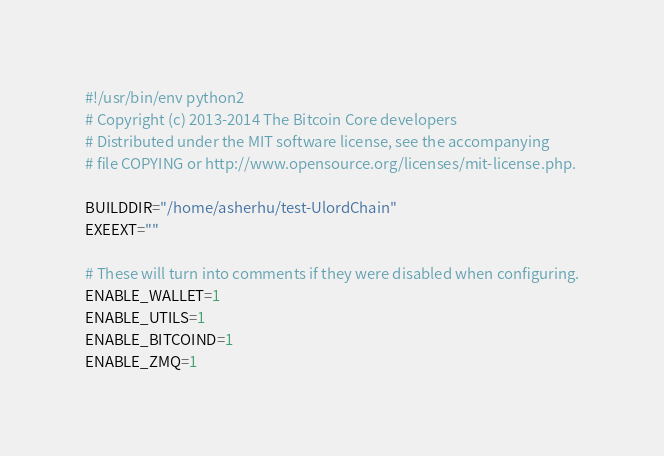<code> <loc_0><loc_0><loc_500><loc_500><_Python_>#!/usr/bin/env python2
# Copyright (c) 2013-2014 The Bitcoin Core developers
# Distributed under the MIT software license, see the accompanying
# file COPYING or http://www.opensource.org/licenses/mit-license.php.

BUILDDIR="/home/asherhu/test-UlordChain"
EXEEXT=""

# These will turn into comments if they were disabled when configuring.
ENABLE_WALLET=1
ENABLE_UTILS=1
ENABLE_BITCOIND=1
ENABLE_ZMQ=1


</code> 